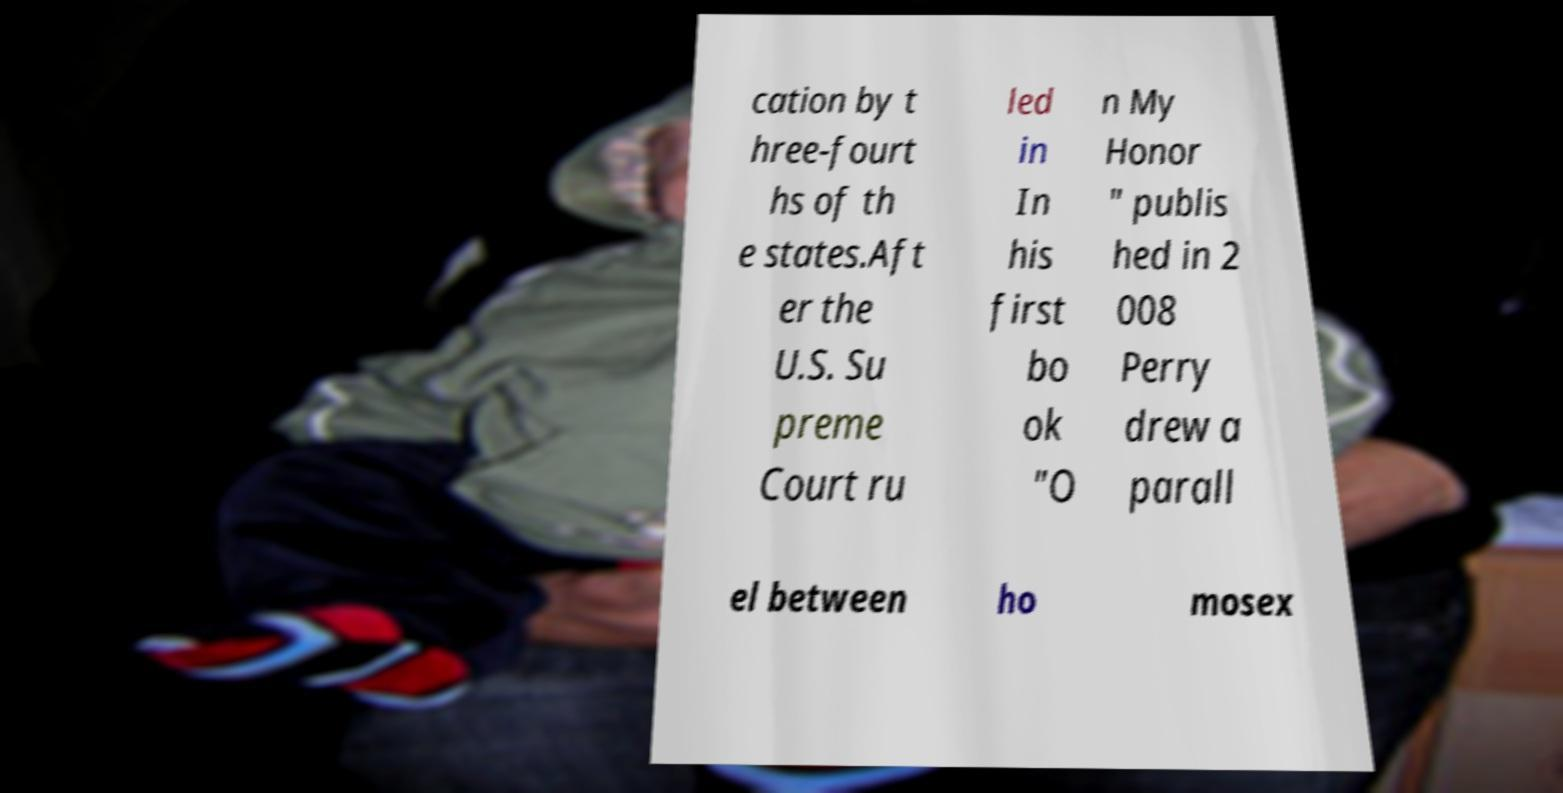What messages or text are displayed in this image? I need them in a readable, typed format. cation by t hree-fourt hs of th e states.Aft er the U.S. Su preme Court ru led in In his first bo ok "O n My Honor " publis hed in 2 008 Perry drew a parall el between ho mosex 